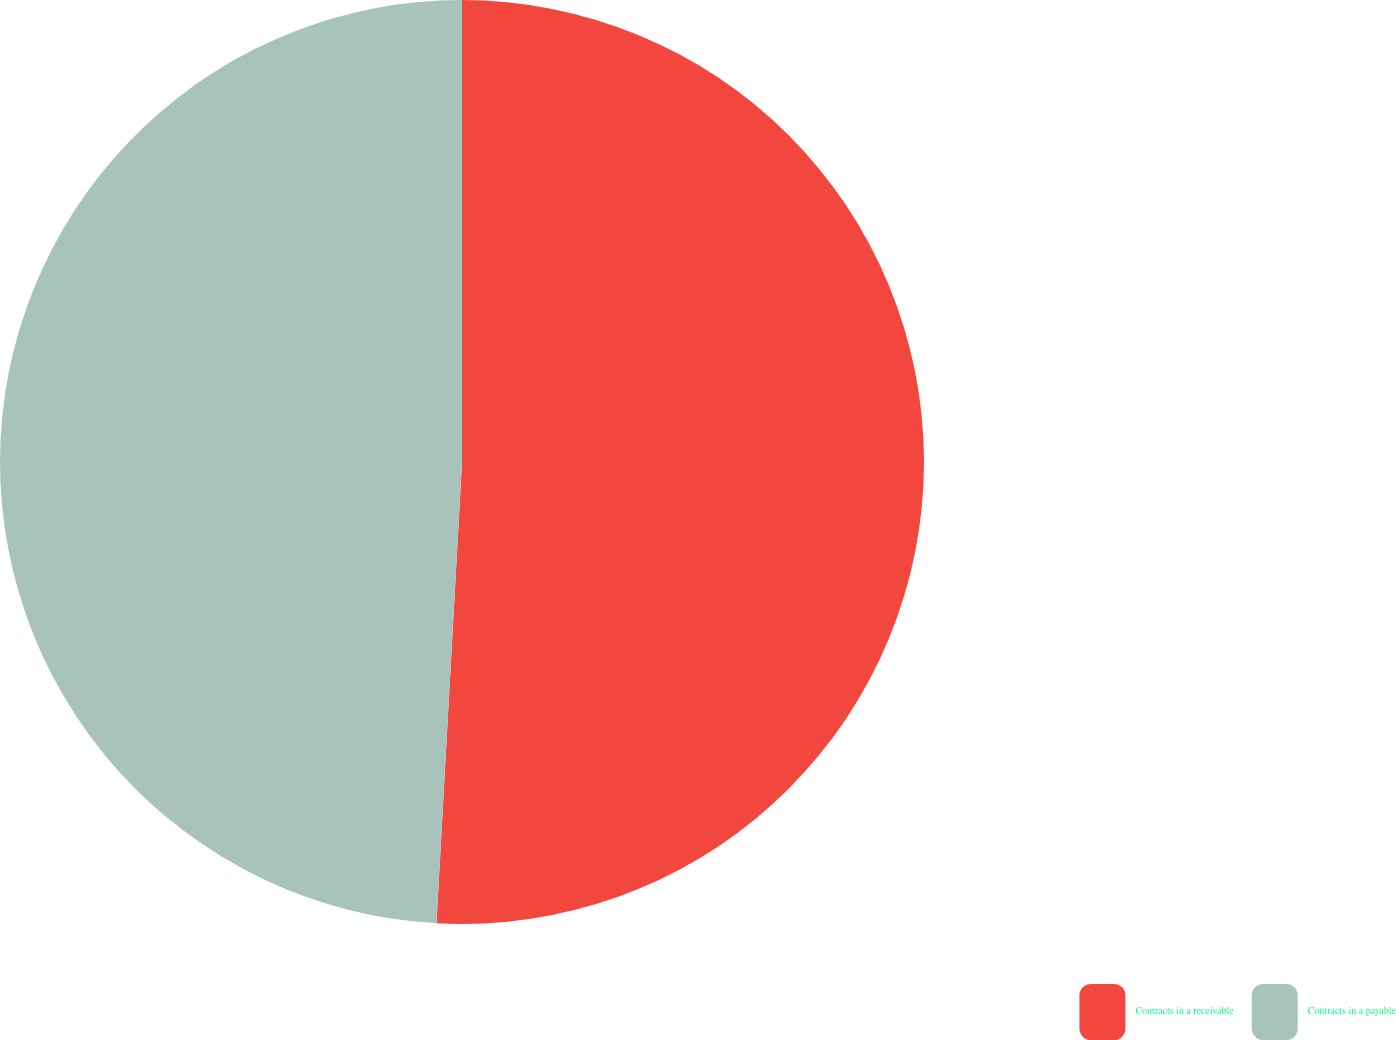<chart> <loc_0><loc_0><loc_500><loc_500><pie_chart><fcel>Contracts in a receivable<fcel>Contracts in a payable<nl><fcel>50.88%<fcel>49.12%<nl></chart> 